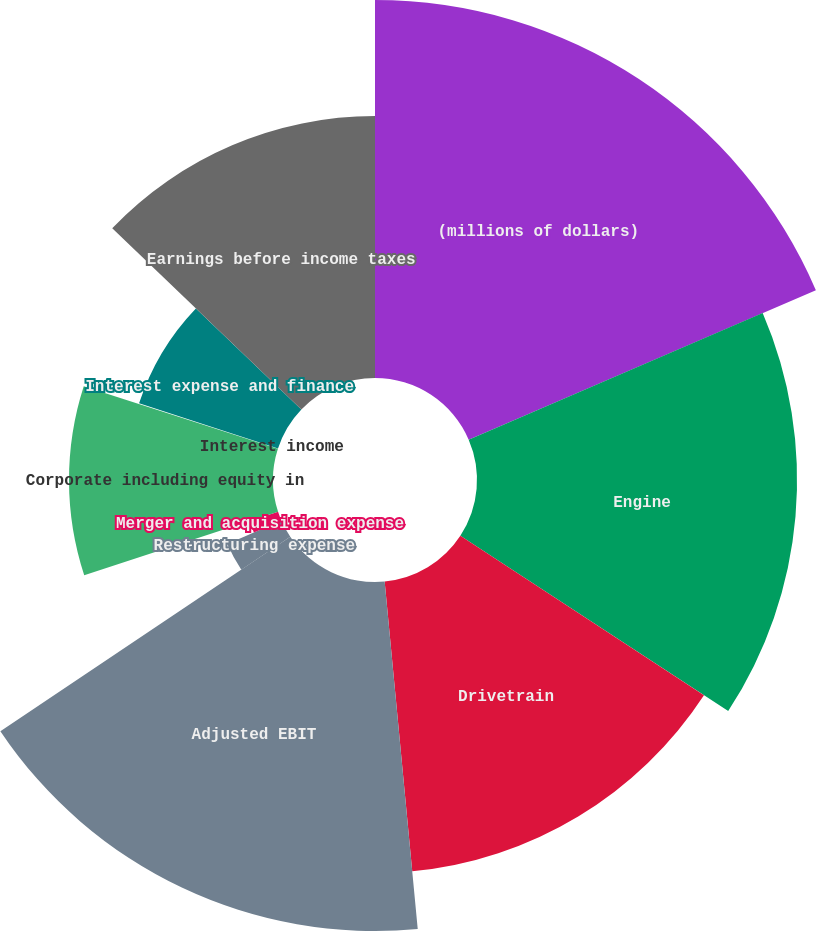<chart> <loc_0><loc_0><loc_500><loc_500><pie_chart><fcel>(millions of dollars)<fcel>Engine<fcel>Drivetrain<fcel>Adjusted EBIT<fcel>Restructuring expense<fcel>Merger and acquisition expense<fcel>Corporate including equity in<fcel>Interest income<fcel>Interest expense and finance<fcel>Earnings before income taxes<nl><fcel>18.53%<fcel>15.69%<fcel>14.27%<fcel>17.11%<fcel>2.89%<fcel>1.47%<fcel>10.0%<fcel>0.04%<fcel>7.16%<fcel>12.84%<nl></chart> 